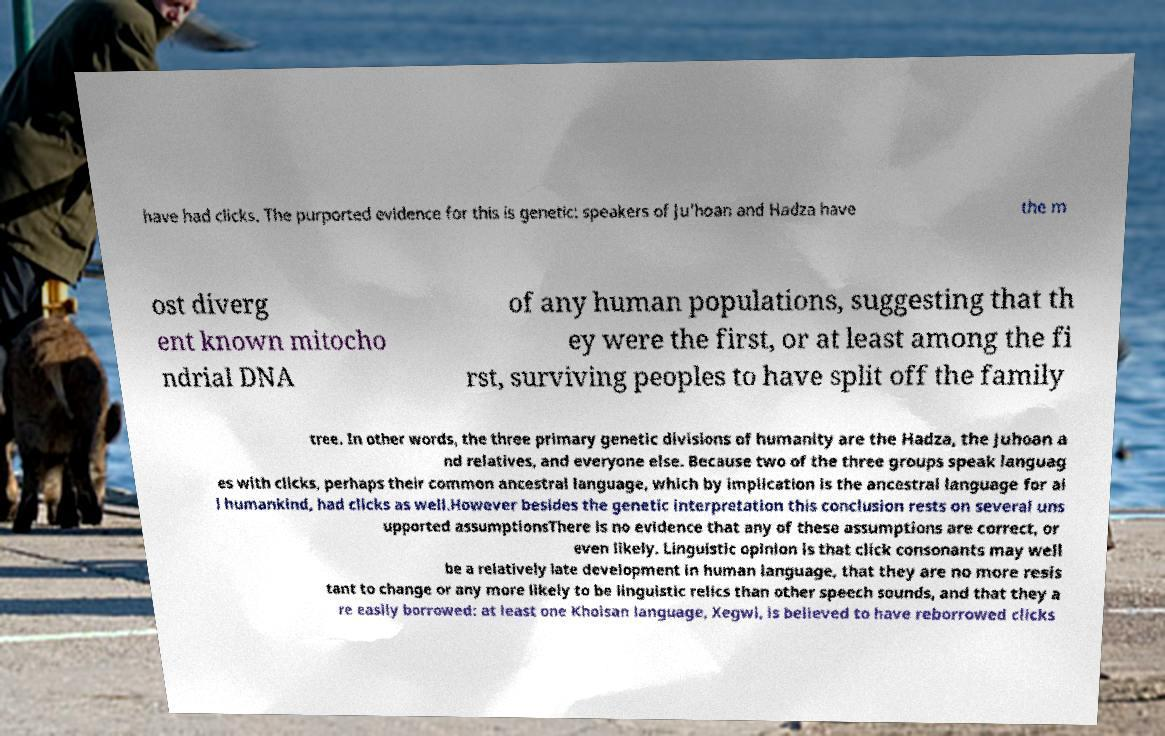Please read and relay the text visible in this image. What does it say? have had clicks. The purported evidence for this is genetic: speakers of Ju'hoan and Hadza have the m ost diverg ent known mitocho ndrial DNA of any human populations, suggesting that th ey were the first, or at least among the fi rst, surviving peoples to have split off the family tree. In other words, the three primary genetic divisions of humanity are the Hadza, the Juhoan a nd relatives, and everyone else. Because two of the three groups speak languag es with clicks, perhaps their common ancestral language, which by implication is the ancestral language for al l humankind, had clicks as well.However besides the genetic interpretation this conclusion rests on several uns upported assumptionsThere is no evidence that any of these assumptions are correct, or even likely. Linguistic opinion is that click consonants may well be a relatively late development in human language, that they are no more resis tant to change or any more likely to be linguistic relics than other speech sounds, and that they a re easily borrowed: at least one Khoisan language, Xegwi, is believed to have reborrowed clicks 